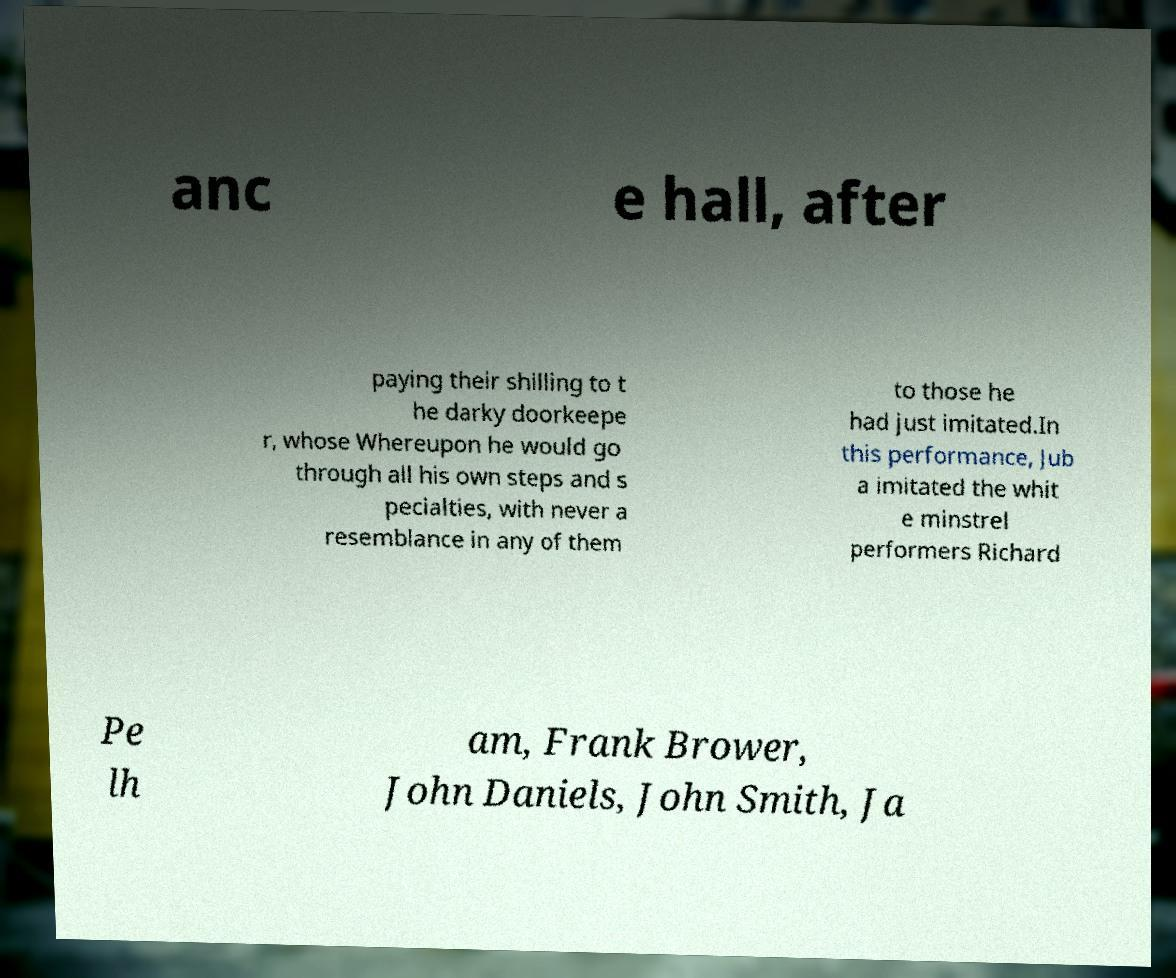I need the written content from this picture converted into text. Can you do that? anc e hall, after paying their shilling to t he darky doorkeepe r, whose Whereupon he would go through all his own steps and s pecialties, with never a resemblance in any of them to those he had just imitated.In this performance, Jub a imitated the whit e minstrel performers Richard Pe lh am, Frank Brower, John Daniels, John Smith, Ja 